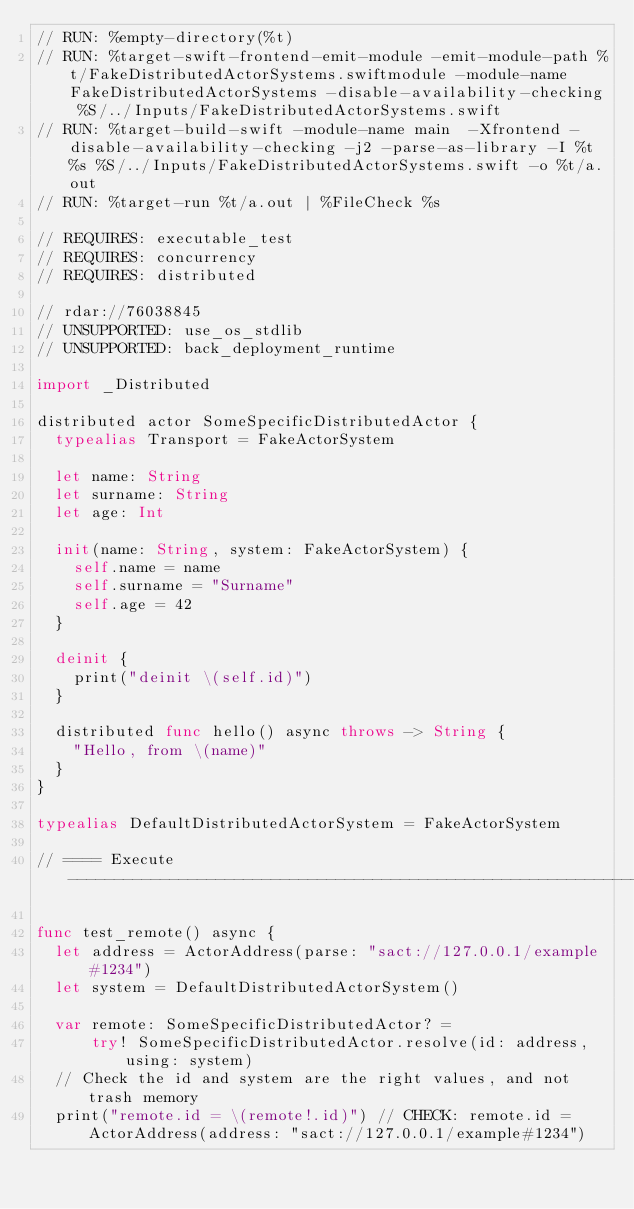<code> <loc_0><loc_0><loc_500><loc_500><_Swift_>// RUN: %empty-directory(%t)
// RUN: %target-swift-frontend-emit-module -emit-module-path %t/FakeDistributedActorSystems.swiftmodule -module-name FakeDistributedActorSystems -disable-availability-checking %S/../Inputs/FakeDistributedActorSystems.swift
// RUN: %target-build-swift -module-name main  -Xfrontend -disable-availability-checking -j2 -parse-as-library -I %t %s %S/../Inputs/FakeDistributedActorSystems.swift -o %t/a.out
// RUN: %target-run %t/a.out | %FileCheck %s

// REQUIRES: executable_test
// REQUIRES: concurrency
// REQUIRES: distributed

// rdar://76038845
// UNSUPPORTED: use_os_stdlib
// UNSUPPORTED: back_deployment_runtime

import _Distributed

distributed actor SomeSpecificDistributedActor {
  typealias Transport = FakeActorSystem

  let name: String
  let surname: String
  let age: Int

  init(name: String, system: FakeActorSystem) {
    self.name = name
    self.surname = "Surname"
    self.age = 42
  }

  deinit {
    print("deinit \(self.id)")
  }

  distributed func hello() async throws -> String {
    "Hello, from \(name)"
  }
}

typealias DefaultDistributedActorSystem = FakeActorSystem

// ==== Execute ----------------------------------------------------------------

func test_remote() async {
  let address = ActorAddress(parse: "sact://127.0.0.1/example#1234")
  let system = DefaultDistributedActorSystem()

  var remote: SomeSpecificDistributedActor? =
      try! SomeSpecificDistributedActor.resolve(id: address, using: system)
  // Check the id and system are the right values, and not trash memory
  print("remote.id = \(remote!.id)") // CHECK: remote.id = ActorAddress(address: "sact://127.0.0.1/example#1234")</code> 